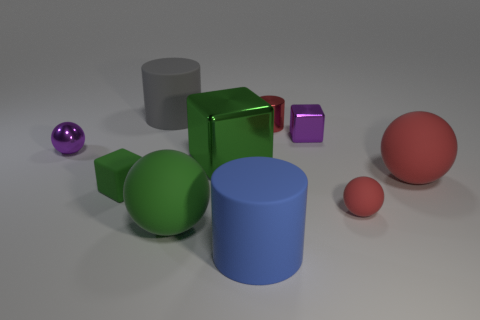Is the number of rubber cubes in front of the gray object the same as the number of large green objects that are behind the big green matte object?
Your response must be concise. Yes. There is a green object to the right of the green ball; how big is it?
Make the answer very short. Large. Is there a brown sphere that has the same material as the small red sphere?
Offer a terse response. No. Is the color of the metallic cube behind the large green shiny object the same as the big metallic cube?
Provide a short and direct response. No. Are there an equal number of small red cylinders on the right side of the large red sphere and tiny yellow cylinders?
Your answer should be very brief. Yes. Is there a big matte ball of the same color as the small metal cylinder?
Offer a very short reply. Yes. Is the green shiny object the same size as the matte block?
Provide a short and direct response. No. There is a block behind the purple shiny object to the left of the tiny red metallic thing; what is its size?
Provide a short and direct response. Small. There is a matte thing that is both behind the tiny green thing and in front of the big gray cylinder; what size is it?
Offer a very short reply. Large. How many green rubber objects are the same size as the blue matte thing?
Provide a short and direct response. 1. 